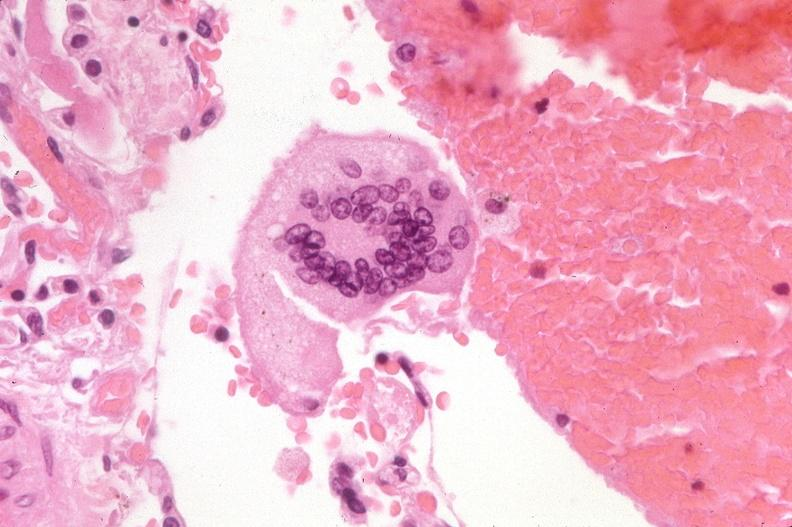does pancreas show lung, multinucleated foreign body giant cell?
Answer the question using a single word or phrase. No 